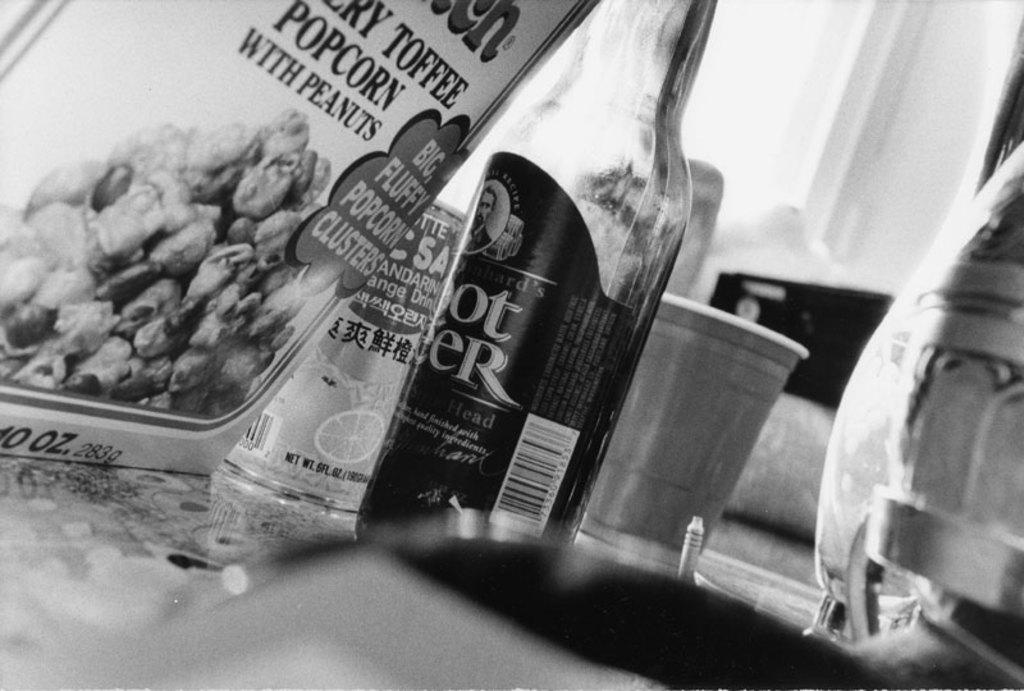What is the color scheme of the image? The image is black and white. What type of container is present in the image? There is a glass bottle in the image. What other objects can be seen in the image? There is a glass, a tin, and a paper in the image. Where are these objects located? All objects are placed on a table. How many degrees of separation are there between the cattle and the quicksand in the image? There is no cattle or quicksand present in the image, so it is not possible to determine the number of degrees of separation between them. 